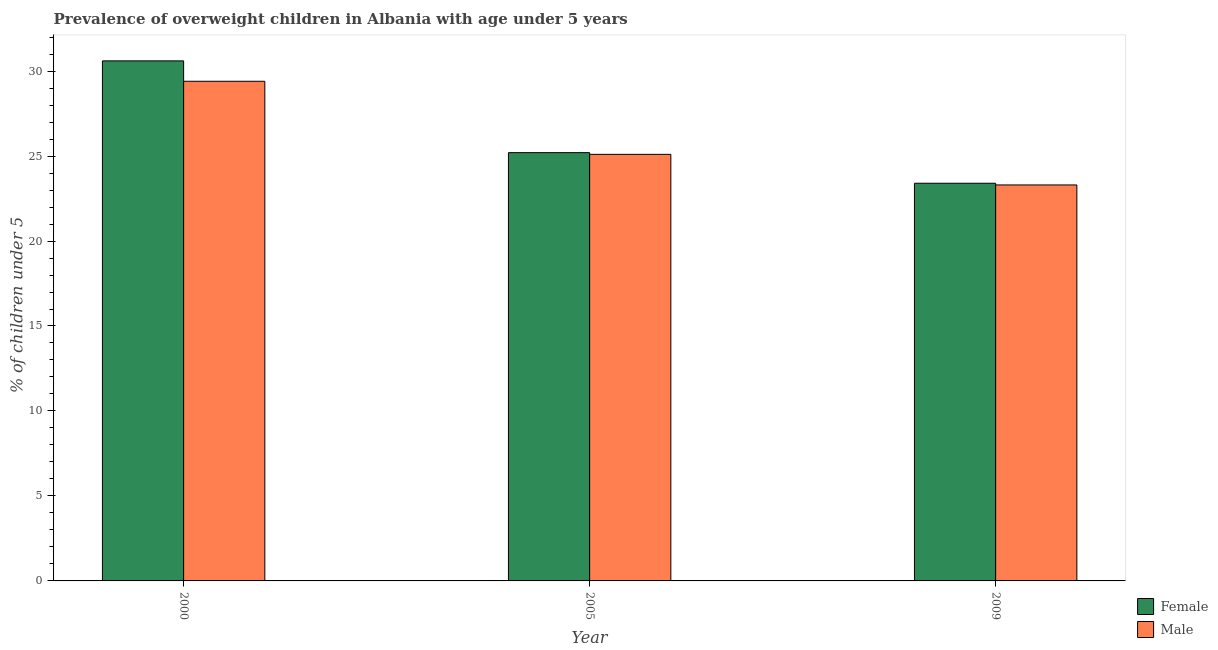How many different coloured bars are there?
Offer a very short reply. 2. How many groups of bars are there?
Your answer should be compact. 3. Are the number of bars on each tick of the X-axis equal?
Offer a very short reply. Yes. How many bars are there on the 1st tick from the left?
Ensure brevity in your answer.  2. In how many cases, is the number of bars for a given year not equal to the number of legend labels?
Provide a short and direct response. 0. What is the percentage of obese female children in 2009?
Your answer should be compact. 23.4. Across all years, what is the maximum percentage of obese female children?
Provide a succinct answer. 30.6. Across all years, what is the minimum percentage of obese male children?
Make the answer very short. 23.3. What is the total percentage of obese male children in the graph?
Your response must be concise. 77.8. What is the difference between the percentage of obese female children in 2005 and that in 2009?
Provide a succinct answer. 1.8. What is the difference between the percentage of obese female children in 2009 and the percentage of obese male children in 2000?
Provide a succinct answer. -7.2. What is the average percentage of obese male children per year?
Your response must be concise. 25.93. In the year 2009, what is the difference between the percentage of obese male children and percentage of obese female children?
Keep it short and to the point. 0. What is the ratio of the percentage of obese male children in 2005 to that in 2009?
Keep it short and to the point. 1.08. Is the percentage of obese female children in 2000 less than that in 2009?
Keep it short and to the point. No. Is the difference between the percentage of obese male children in 2000 and 2005 greater than the difference between the percentage of obese female children in 2000 and 2005?
Provide a short and direct response. No. What is the difference between the highest and the second highest percentage of obese female children?
Your answer should be very brief. 5.4. What is the difference between the highest and the lowest percentage of obese male children?
Your response must be concise. 6.1. Is the sum of the percentage of obese male children in 2000 and 2009 greater than the maximum percentage of obese female children across all years?
Provide a succinct answer. Yes. What does the 1st bar from the right in 2005 represents?
Your response must be concise. Male. How many bars are there?
Provide a short and direct response. 6. What is the title of the graph?
Your response must be concise. Prevalence of overweight children in Albania with age under 5 years. Does "Subsidies" appear as one of the legend labels in the graph?
Offer a terse response. No. What is the label or title of the X-axis?
Keep it short and to the point. Year. What is the label or title of the Y-axis?
Your answer should be compact.  % of children under 5. What is the  % of children under 5 in Female in 2000?
Provide a succinct answer. 30.6. What is the  % of children under 5 in Male in 2000?
Keep it short and to the point. 29.4. What is the  % of children under 5 in Female in 2005?
Make the answer very short. 25.2. What is the  % of children under 5 of Male in 2005?
Keep it short and to the point. 25.1. What is the  % of children under 5 in Female in 2009?
Provide a short and direct response. 23.4. What is the  % of children under 5 in Male in 2009?
Your answer should be compact. 23.3. Across all years, what is the maximum  % of children under 5 of Female?
Provide a succinct answer. 30.6. Across all years, what is the maximum  % of children under 5 in Male?
Offer a very short reply. 29.4. Across all years, what is the minimum  % of children under 5 of Female?
Provide a succinct answer. 23.4. Across all years, what is the minimum  % of children under 5 in Male?
Provide a succinct answer. 23.3. What is the total  % of children under 5 in Female in the graph?
Your answer should be compact. 79.2. What is the total  % of children under 5 in Male in the graph?
Your answer should be compact. 77.8. What is the difference between the  % of children under 5 in Female in 2000 and that in 2005?
Your answer should be very brief. 5.4. What is the difference between the  % of children under 5 of Male in 2000 and that in 2005?
Give a very brief answer. 4.3. What is the difference between the  % of children under 5 in Male in 2000 and that in 2009?
Offer a very short reply. 6.1. What is the difference between the  % of children under 5 in Male in 2005 and that in 2009?
Provide a succinct answer. 1.8. What is the difference between the  % of children under 5 in Female in 2000 and the  % of children under 5 in Male in 2005?
Ensure brevity in your answer.  5.5. What is the difference between the  % of children under 5 of Female in 2000 and the  % of children under 5 of Male in 2009?
Give a very brief answer. 7.3. What is the average  % of children under 5 of Female per year?
Offer a terse response. 26.4. What is the average  % of children under 5 of Male per year?
Give a very brief answer. 25.93. What is the ratio of the  % of children under 5 of Female in 2000 to that in 2005?
Ensure brevity in your answer.  1.21. What is the ratio of the  % of children under 5 of Male in 2000 to that in 2005?
Provide a succinct answer. 1.17. What is the ratio of the  % of children under 5 of Female in 2000 to that in 2009?
Ensure brevity in your answer.  1.31. What is the ratio of the  % of children under 5 in Male in 2000 to that in 2009?
Provide a short and direct response. 1.26. What is the ratio of the  % of children under 5 of Female in 2005 to that in 2009?
Offer a terse response. 1.08. What is the ratio of the  % of children under 5 in Male in 2005 to that in 2009?
Your response must be concise. 1.08. 